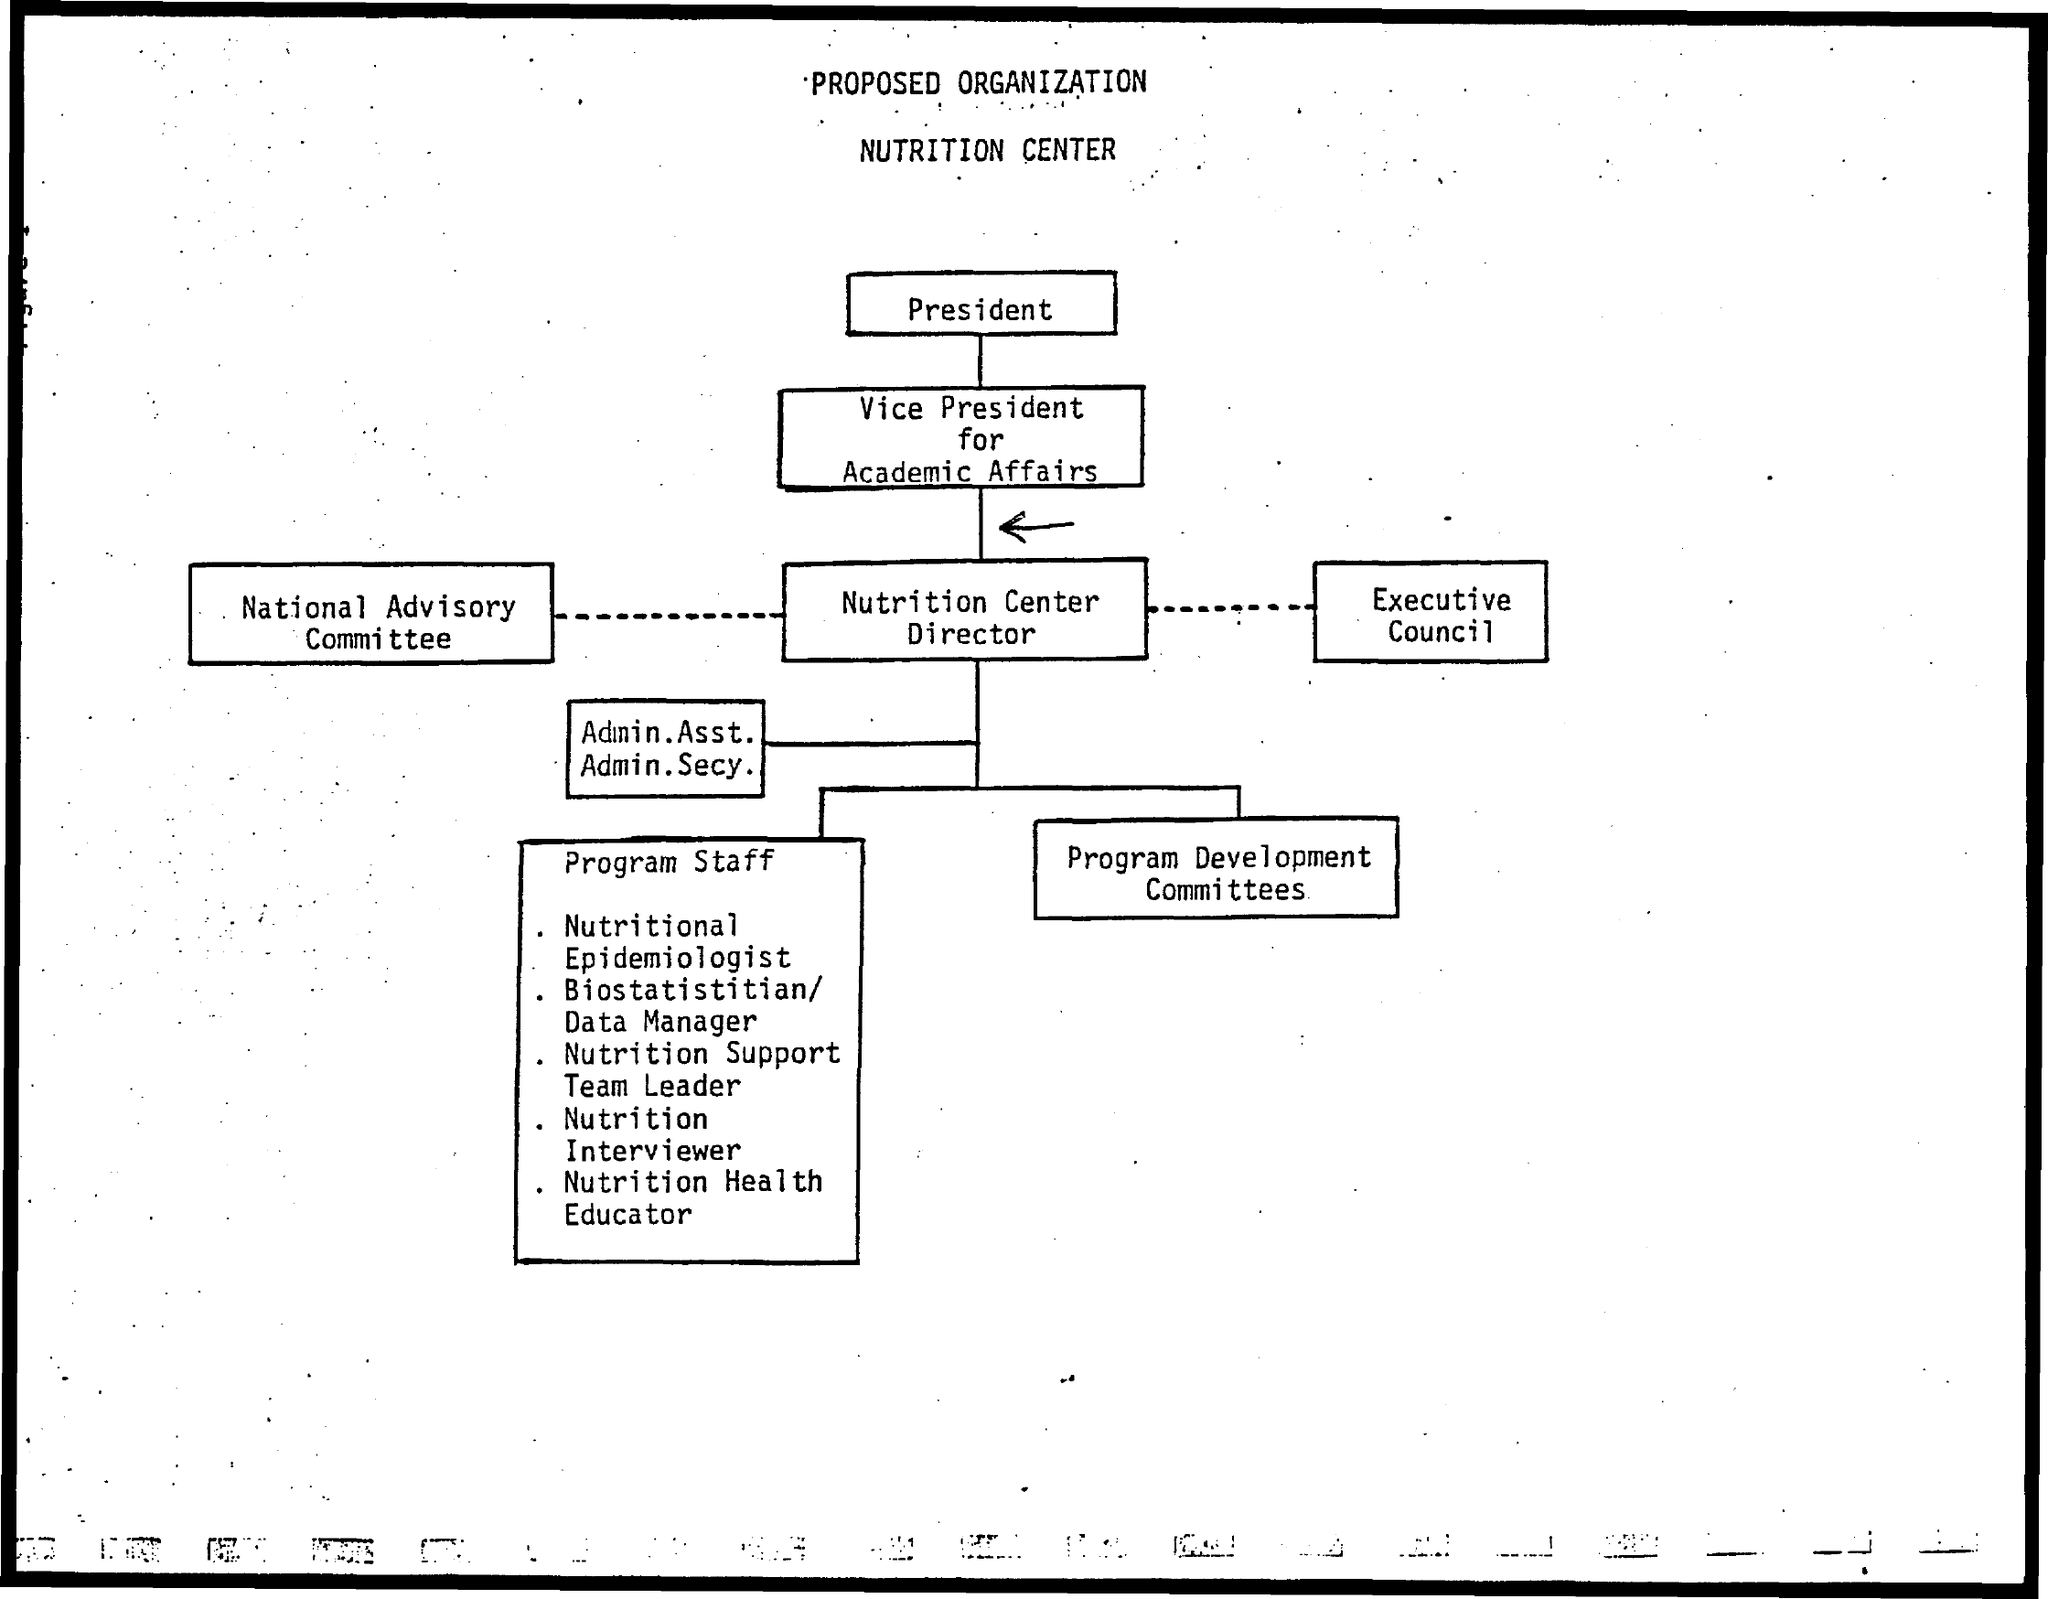Give some essential details in this illustration. The Nutrition Center is under the organizational structure. 